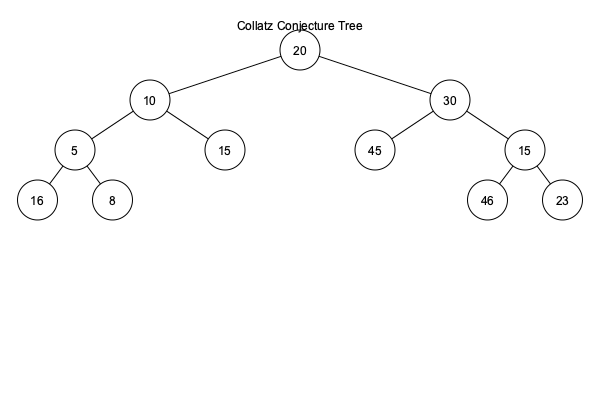In the Collatz conjecture tree diagram shown above, starting from 20, what is the sum of all unique numbers encountered in the sequence before reaching 1? Let's break this down step-by-step:

1) We start with 20 at the root of the tree.

2) Following the Collatz conjecture rules:
   - If the number is even, divide by 2
   - If the number is odd, multiply by 3 and add 1

3) The sequence from 20 goes as follows:
   20 → 10 → 5 → 16 → 8 → 4 → 2 → 1

4) Let's list out the unique numbers in this sequence:
   20, 10, 5, 16, 8, 4, 2

5) Now, we need to sum these unique numbers:
   $20 + 10 + 5 + 16 + 8 + 4 + 2 = 65$

6) Note that we don't include 1 in our sum, as the question asks for numbers encountered before reaching 1.

Therefore, the sum of all unique numbers encountered in the sequence starting from 20 before reaching 1 is 65.
Answer: 65 